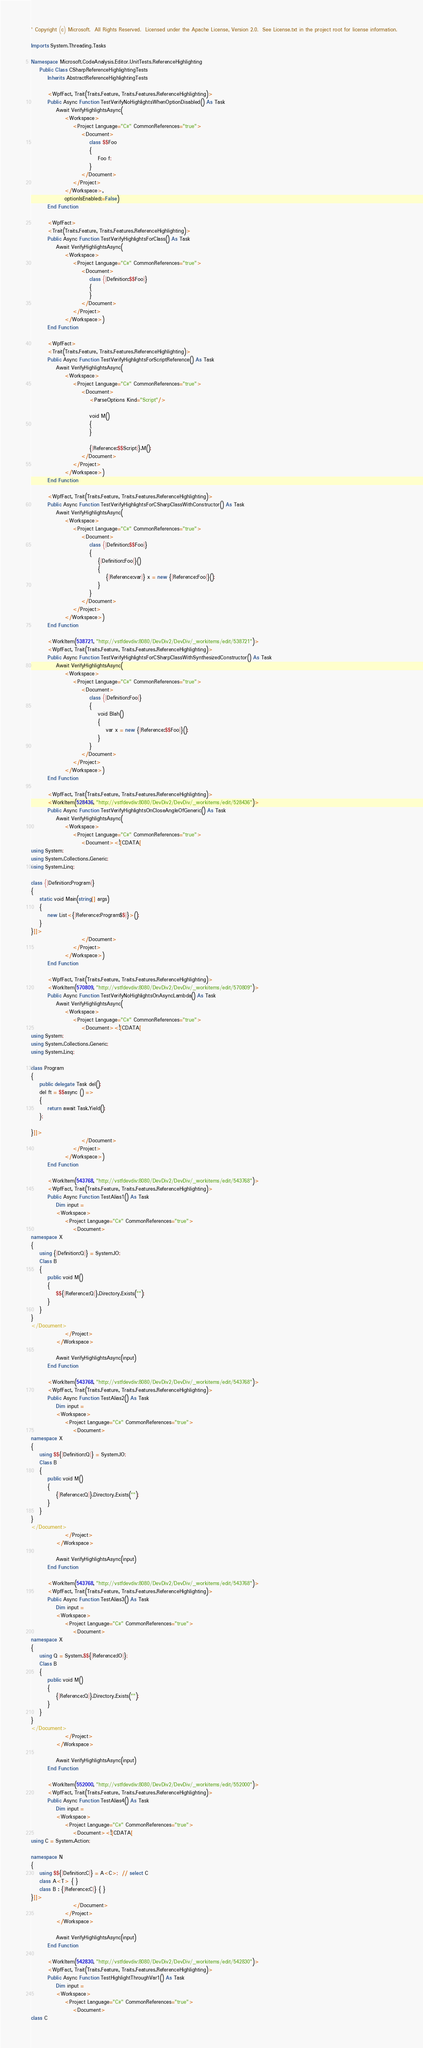<code> <loc_0><loc_0><loc_500><loc_500><_VisualBasic_>' Copyright (c) Microsoft.  All Rights Reserved.  Licensed under the Apache License, Version 2.0.  See License.txt in the project root for license information.

Imports System.Threading.Tasks

Namespace Microsoft.CodeAnalysis.Editor.UnitTests.ReferenceHighlighting
    Public Class CSharpReferenceHighlightingTests
        Inherits AbstractReferenceHighlightingTests

        <WpfFact, Trait(Traits.Feature, Traits.Features.ReferenceHighlighting)>
        Public Async Function TestVerifyNoHighlightsWhenOptionDisabled() As Task
            Await VerifyHighlightsAsync(
                <Workspace>
                    <Project Language="C#" CommonReferences="true">
                        <Document>
                            class $$Foo
                            {
                                Foo f;
                            }
                        </Document>
                    </Project>
                </Workspace>,
                optionIsEnabled:=False)
        End Function

        <WpfFact>
        <Trait(Traits.Feature, Traits.Features.ReferenceHighlighting)>
        Public Async Function TestVerifyHighlightsForClass() As Task
            Await VerifyHighlightsAsync(
                <Workspace>
                    <Project Language="C#" CommonReferences="true">
                        <Document>
                            class {|Definition:$$Foo|}
                            {
                            }
                        </Document>
                    </Project>
                </Workspace>)
        End Function

        <WpfFact>
        <Trait(Traits.Feature, Traits.Features.ReferenceHighlighting)>
        Public Async Function TestVerifyHighlightsForScriptReference() As Task
            Await VerifyHighlightsAsync(
                <Workspace>
                    <Project Language="C#" CommonReferences="true">
                        <Document>
                            <ParseOptions Kind="Script"/>

                            void M()
                            {
                            }

                            {|Reference:$$Script|}.M();
                        </Document>
                    </Project>
                </Workspace>)
        End Function

        <WpfFact, Trait(Traits.Feature, Traits.Features.ReferenceHighlighting)>
        Public Async Function TestVerifyHighlightsForCSharpClassWithConstructor() As Task
            Await VerifyHighlightsAsync(
                <Workspace>
                    <Project Language="C#" CommonReferences="true">
                        <Document>
                            class {|Definition:$$Foo|}
                            {
                                {|Definition:Foo|}()
                                {
                                    {|Reference:var|} x = new {|Reference:Foo|}();
                                }
                            }
                        </Document>
                    </Project>
                </Workspace>)
        End Function

        <WorkItem(538721, "http://vstfdevdiv:8080/DevDiv2/DevDiv/_workitems/edit/538721")>
        <WpfFact, Trait(Traits.Feature, Traits.Features.ReferenceHighlighting)>
        Public Async Function TestVerifyHighlightsForCSharpClassWithSynthesizedConstructor() As Task
            Await VerifyHighlightsAsync(
                <Workspace>
                    <Project Language="C#" CommonReferences="true">
                        <Document>
                            class {|Definition:Foo|}
                            {
                                void Blah()
                                {
                                    var x = new {|Reference:$$Foo|}();
                                }
                            }
                        </Document>
                    </Project>
                </Workspace>)
        End Function

        <WpfFact, Trait(Traits.Feature, Traits.Features.ReferenceHighlighting)>
        <WorkItem(528436, "http://vstfdevdiv:8080/DevDiv2/DevDiv/_workitems/edit/528436")>
        Public Async Function TestVerifyHighlightsOnCloseAngleOfGeneric() As Task
            Await VerifyHighlightsAsync(
                <Workspace>
                    <Project Language="C#" CommonReferences="true">
                        <Document><![CDATA[
using System;
using System.Collections.Generic;
using System.Linq;

class {|Definition:Program|}
{
    static void Main(string[] args)
    {
        new List<{|Reference:Program$$|}>();
    }
}]]>
                        </Document>
                    </Project>
                </Workspace>)
        End Function

        <WpfFact, Trait(Traits.Feature, Traits.Features.ReferenceHighlighting)>
        <WorkItem(570809, "http://vstfdevdiv:8080/DevDiv2/DevDiv/_workitems/edit/570809")>
        Public Async Function TestVerifyNoHighlightsOnAsyncLambda() As Task
            Await VerifyHighlightsAsync(
                <Workspace>
                    <Project Language="C#" CommonReferences="true">
                        <Document><![CDATA[
using System;
using System.Collections.Generic;
using System.Linq;

class Program
{
    public delegate Task del();
    del ft = $$async () =>
    {
        return await Task.Yield();
    };

}]]>
                        </Document>
                    </Project>
                </Workspace>)
        End Function

        <WorkItem(543768, "http://vstfdevdiv:8080/DevDiv2/DevDiv/_workitems/edit/543768")>
        <WpfFact, Trait(Traits.Feature, Traits.Features.ReferenceHighlighting)>
        Public Async Function TestAlias1() As Task
            Dim input =
            <Workspace>
                <Project Language="C#" CommonReferences="true">
                    <Document>
namespace X
{
    using {|Definition:Q|} = System.IO;
    Class B
    {
        public void M()
        {
            $${|Reference:Q|}.Directory.Exists("");
        }
    }
}
</Document>
                </Project>
            </Workspace>

            Await VerifyHighlightsAsync(input)
        End Function

        <WorkItem(543768, "http://vstfdevdiv:8080/DevDiv2/DevDiv/_workitems/edit/543768")>
        <WpfFact, Trait(Traits.Feature, Traits.Features.ReferenceHighlighting)>
        Public Async Function TestAlias2() As Task
            Dim input =
            <Workspace>
                <Project Language="C#" CommonReferences="true">
                    <Document>
namespace X
{
    using $${|Definition:Q|} = System.IO;
    Class B
    {
        public void M()
        {
            {|Reference:Q|}.Directory.Exists("");
        }
    }
}
</Document>
                </Project>
            </Workspace>

            Await VerifyHighlightsAsync(input)
        End Function

        <WorkItem(543768, "http://vstfdevdiv:8080/DevDiv2/DevDiv/_workitems/edit/543768")>
        <WpfFact, Trait(Traits.Feature, Traits.Features.ReferenceHighlighting)>
        Public Async Function TestAlias3() As Task
            Dim input =
            <Workspace>
                <Project Language="C#" CommonReferences="true">
                    <Document>
namespace X
{
    using Q = System.$${|Reference:IO|};
    Class B
    {
        public void M()
        {
            {|Reference:Q|}.Directory.Exists("");
        }
    }
}
</Document>
                </Project>
            </Workspace>

            Await VerifyHighlightsAsync(input)
        End Function

        <WorkItem(552000, "http://vstfdevdiv:8080/DevDiv2/DevDiv/_workitems/edit/552000")>
        <WpfFact, Trait(Traits.Feature, Traits.Features.ReferenceHighlighting)>
        Public Async Function TestAlias4() As Task
            Dim input =
            <Workspace>
                <Project Language="C#" CommonReferences="true">
                    <Document><![CDATA[
using C = System.Action;

namespace N
{
    using $${|Definition:C|} = A<C>;  // select C 
    class A<T> { }
    class B : {|Reference:C|} { }
}]]>
                    </Document>
                </Project>
            </Workspace>

            Await VerifyHighlightsAsync(input)
        End Function

        <WorkItem(542830, "http://vstfdevdiv:8080/DevDiv2/DevDiv/_workitems/edit/542830")>
        <WpfFact, Trait(Traits.Feature, Traits.Features.ReferenceHighlighting)>
        Public Async Function TestHighlightThroughVar1() As Task
            Dim input =
            <Workspace>
                <Project Language="C#" CommonReferences="true">
                    <Document>
class C</code> 